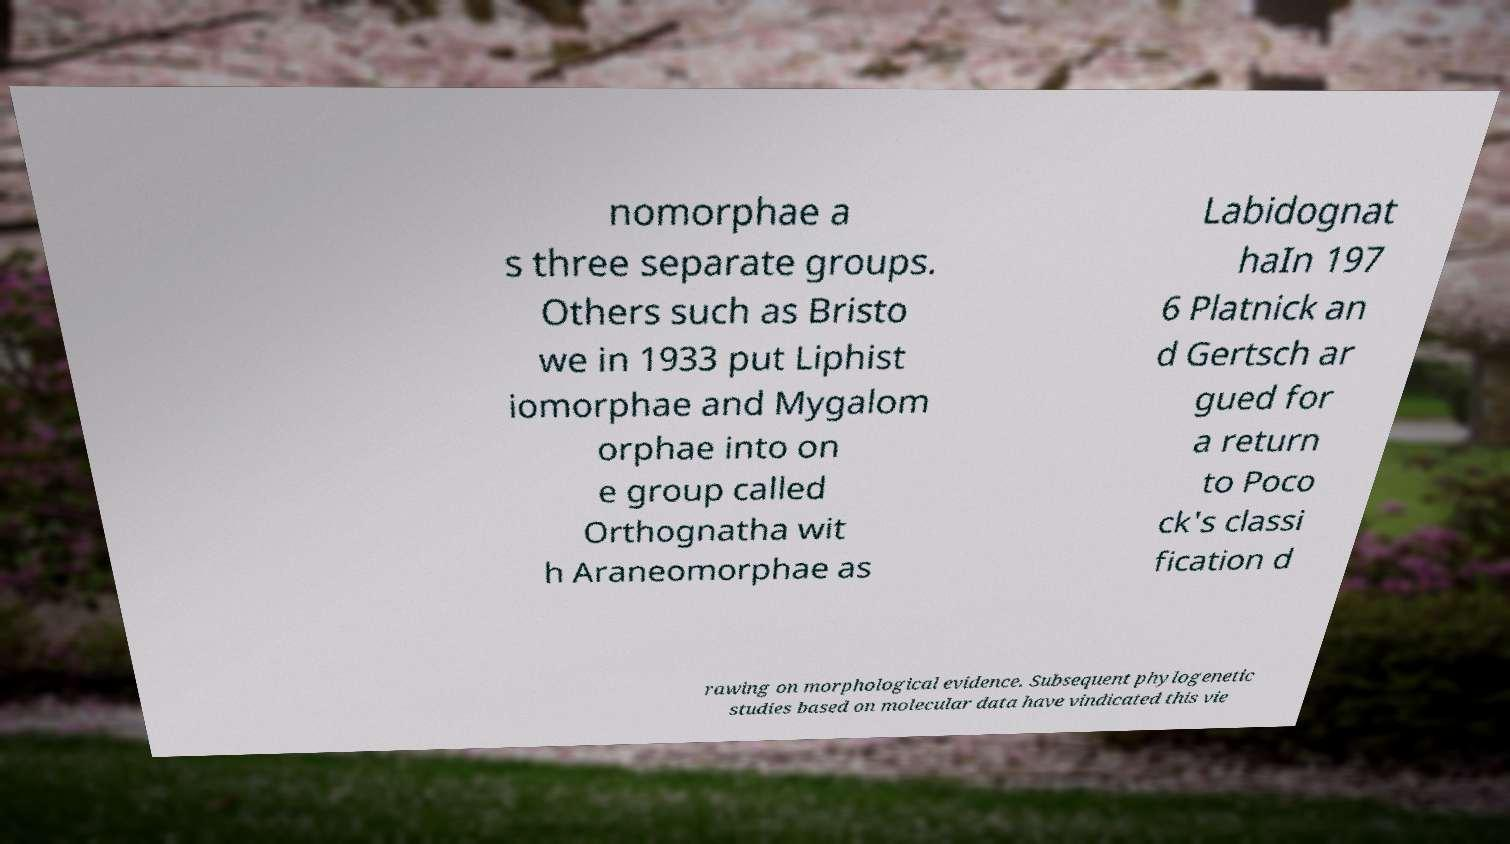Can you read and provide the text displayed in the image?This photo seems to have some interesting text. Can you extract and type it out for me? nomorphae a s three separate groups. Others such as Bristo we in 1933 put Liphist iomorphae and Mygalom orphae into on e group called Orthognatha wit h Araneomorphae as Labidognat haIn 197 6 Platnick an d Gertsch ar gued for a return to Poco ck's classi fication d rawing on morphological evidence. Subsequent phylogenetic studies based on molecular data have vindicated this vie 